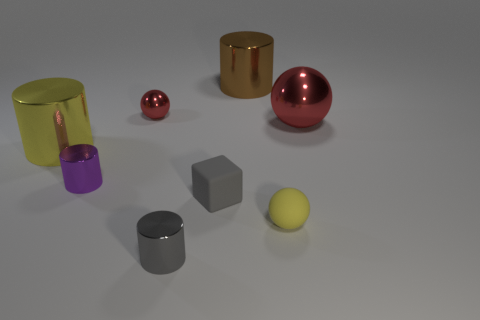Is there any other thing that has the same color as the large sphere?
Your answer should be very brief. Yes. What size is the yellow thing that is right of the rubber object on the left side of the brown thing?
Your answer should be compact. Small. What is the color of the cylinder that is both to the left of the brown metallic thing and behind the purple cylinder?
Give a very brief answer. Yellow. What number of other objects are the same size as the yellow metallic cylinder?
Your response must be concise. 2. There is a purple cylinder; is its size the same as the yellow thing that is right of the yellow metal object?
Give a very brief answer. Yes. There is a ball that is the same size as the brown metal cylinder; what color is it?
Provide a short and direct response. Red. The gray cylinder is what size?
Make the answer very short. Small. Does the small object behind the large yellow thing have the same material as the tiny gray cylinder?
Your response must be concise. Yes. Is the purple shiny thing the same shape as the tiny yellow matte thing?
Provide a short and direct response. No. What shape is the shiny thing behind the red metallic object on the left side of the cylinder in front of the rubber ball?
Keep it short and to the point. Cylinder. 